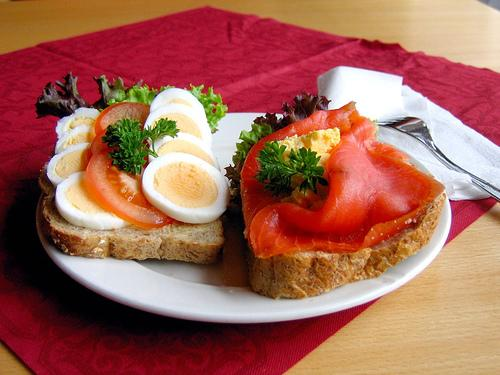Which food came from an unborn animal? egg 